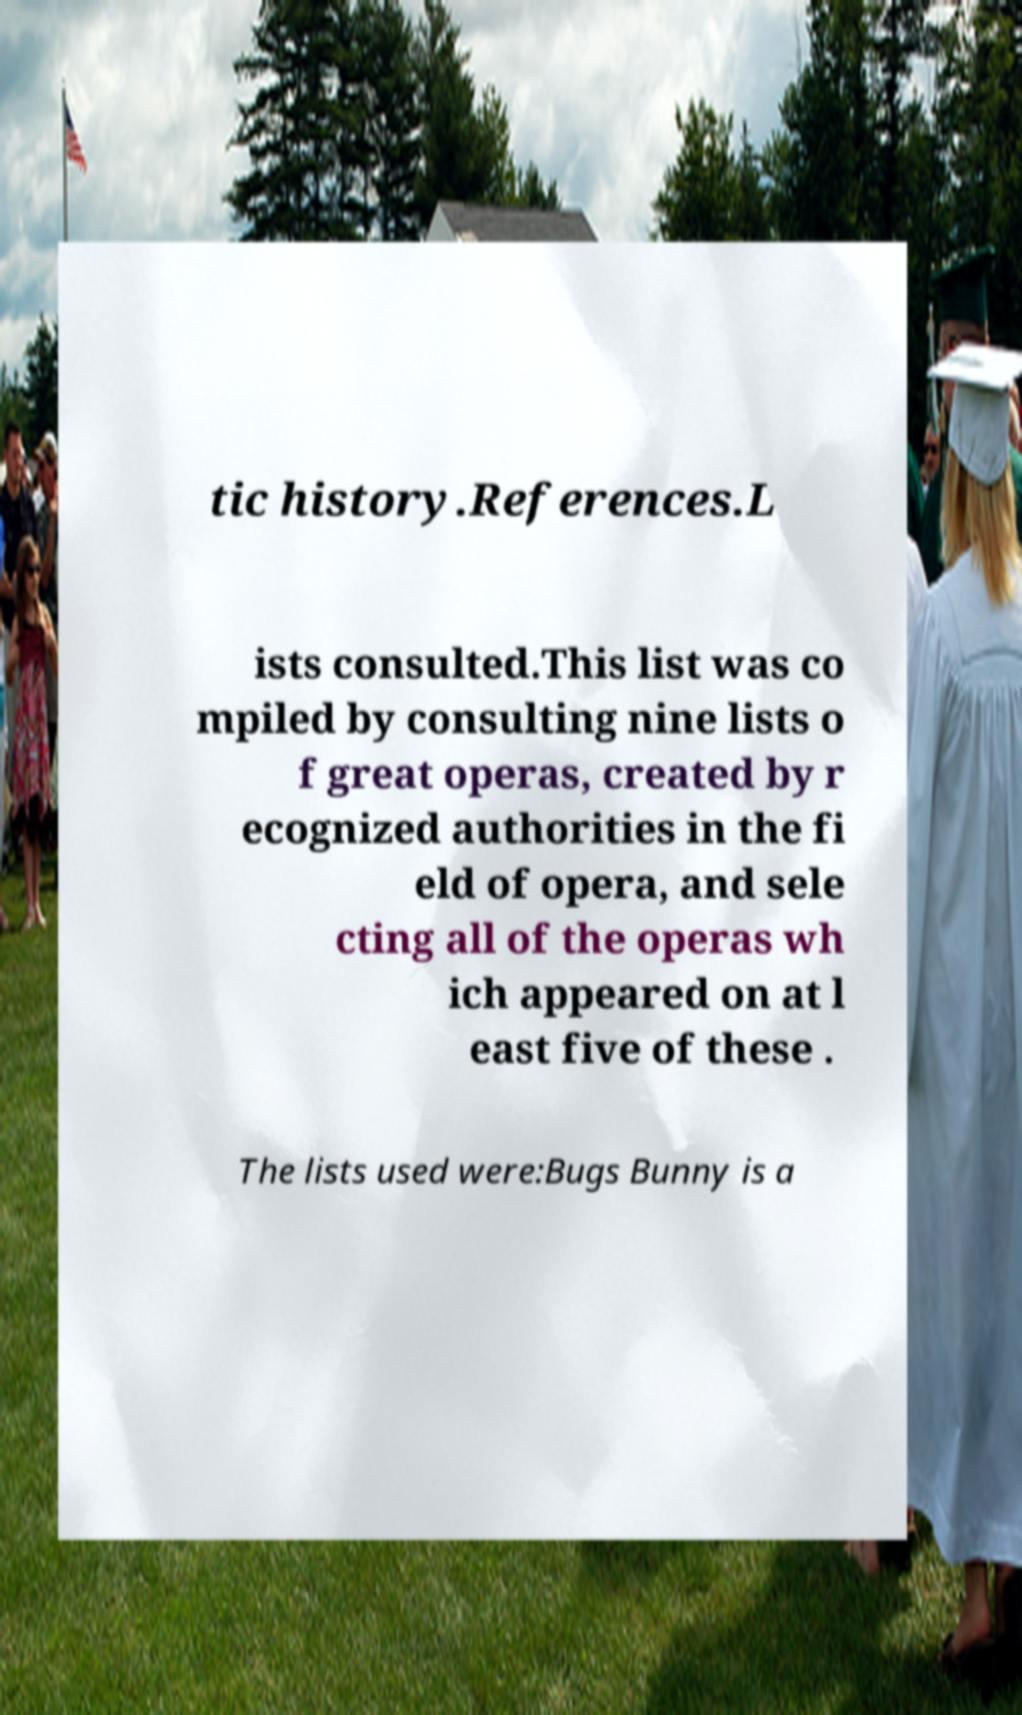Please read and relay the text visible in this image. What does it say? tic history.References.L ists consulted.This list was co mpiled by consulting nine lists o f great operas, created by r ecognized authorities in the fi eld of opera, and sele cting all of the operas wh ich appeared on at l east five of these . The lists used were:Bugs Bunny is a 